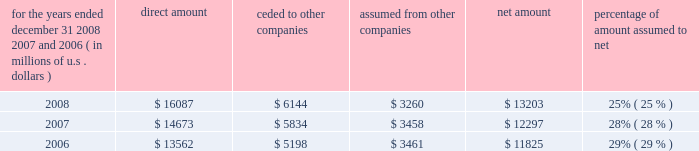S c h e d u l e i v ( continued ) ace limited and subsidiaries s u p p l e m e n t a l i n f o r m a t i o n c o n c e r n i n g r e i n s u r a n c e premiums earned for the years ended december 31 , 2008 , 2007 , and 2006 ( in millions of u.s .
Dollars ) direct amount ceded to companies assumed from other companies net amount percentage of amount assumed to .

In 2008 what was the ratio of the direct amount to the amount ceded to other companies? 
Computations: (16087 / 6144)
Answer: 2.61833. 